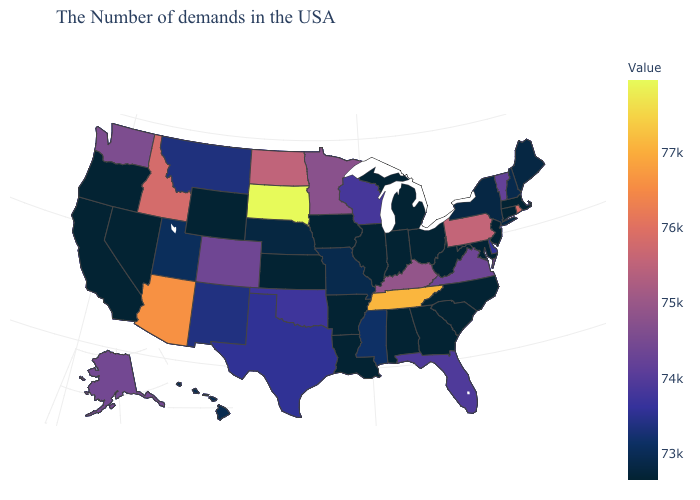Which states hav the highest value in the West?
Be succinct. Arizona. Which states have the lowest value in the USA?
Quick response, please. Massachusetts, Connecticut, New Jersey, Maryland, North Carolina, South Carolina, West Virginia, Ohio, Georgia, Michigan, Indiana, Alabama, Illinois, Louisiana, Arkansas, Iowa, Kansas, Wyoming, Nevada, California, Oregon. Does Idaho have the highest value in the USA?
Answer briefly. No. Which states have the lowest value in the MidWest?
Give a very brief answer. Ohio, Michigan, Indiana, Illinois, Iowa, Kansas. Among the states that border Oklahoma , does Arkansas have the lowest value?
Concise answer only. Yes. Does Wisconsin have a higher value than Hawaii?
Give a very brief answer. Yes. Does Kansas have the lowest value in the USA?
Short answer required. Yes. 